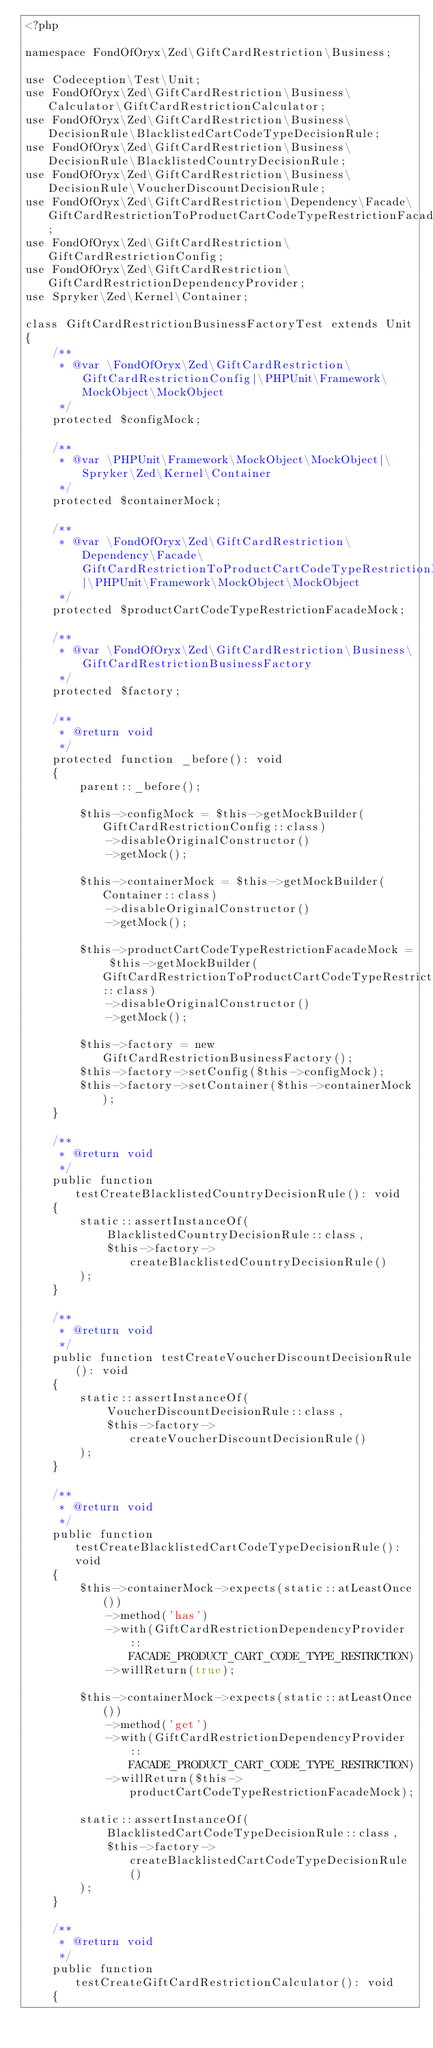Convert code to text. <code><loc_0><loc_0><loc_500><loc_500><_PHP_><?php

namespace FondOfOryx\Zed\GiftCardRestriction\Business;

use Codeception\Test\Unit;
use FondOfOryx\Zed\GiftCardRestriction\Business\Calculator\GiftCardRestrictionCalculator;
use FondOfOryx\Zed\GiftCardRestriction\Business\DecisionRule\BlacklistedCartCodeTypeDecisionRule;
use FondOfOryx\Zed\GiftCardRestriction\Business\DecisionRule\BlacklistedCountryDecisionRule;
use FondOfOryx\Zed\GiftCardRestriction\Business\DecisionRule\VoucherDiscountDecisionRule;
use FondOfOryx\Zed\GiftCardRestriction\Dependency\Facade\GiftCardRestrictionToProductCartCodeTypeRestrictionFacadeInterface;
use FondOfOryx\Zed\GiftCardRestriction\GiftCardRestrictionConfig;
use FondOfOryx\Zed\GiftCardRestriction\GiftCardRestrictionDependencyProvider;
use Spryker\Zed\Kernel\Container;

class GiftCardRestrictionBusinessFactoryTest extends Unit
{
    /**
     * @var \FondOfOryx\Zed\GiftCardRestriction\GiftCardRestrictionConfig|\PHPUnit\Framework\MockObject\MockObject
     */
    protected $configMock;

    /**
     * @var \PHPUnit\Framework\MockObject\MockObject|\Spryker\Zed\Kernel\Container
     */
    protected $containerMock;

    /**
     * @var \FondOfOryx\Zed\GiftCardRestriction\Dependency\Facade\GiftCardRestrictionToProductCartCodeTypeRestrictionFacadeInterface|\PHPUnit\Framework\MockObject\MockObject
     */
    protected $productCartCodeTypeRestrictionFacadeMock;

    /**
     * @var \FondOfOryx\Zed\GiftCardRestriction\Business\GiftCardRestrictionBusinessFactory
     */
    protected $factory;

    /**
     * @return void
     */
    protected function _before(): void
    {
        parent::_before();

        $this->configMock = $this->getMockBuilder(GiftCardRestrictionConfig::class)
            ->disableOriginalConstructor()
            ->getMock();

        $this->containerMock = $this->getMockBuilder(Container::class)
            ->disableOriginalConstructor()
            ->getMock();

        $this->productCartCodeTypeRestrictionFacadeMock = $this->getMockBuilder(GiftCardRestrictionToProductCartCodeTypeRestrictionFacadeInterface::class)
            ->disableOriginalConstructor()
            ->getMock();

        $this->factory = new GiftCardRestrictionBusinessFactory();
        $this->factory->setConfig($this->configMock);
        $this->factory->setContainer($this->containerMock);
    }

    /**
     * @return void
     */
    public function testCreateBlacklistedCountryDecisionRule(): void
    {
        static::assertInstanceOf(
            BlacklistedCountryDecisionRule::class,
            $this->factory->createBlacklistedCountryDecisionRule()
        );
    }

    /**
     * @return void
     */
    public function testCreateVoucherDiscountDecisionRule(): void
    {
        static::assertInstanceOf(
            VoucherDiscountDecisionRule::class,
            $this->factory->createVoucherDiscountDecisionRule()
        );
    }

    /**
     * @return void
     */
    public function testCreateBlacklistedCartCodeTypeDecisionRule(): void
    {
        $this->containerMock->expects(static::atLeastOnce())
            ->method('has')
            ->with(GiftCardRestrictionDependencyProvider::FACADE_PRODUCT_CART_CODE_TYPE_RESTRICTION)
            ->willReturn(true);

        $this->containerMock->expects(static::atLeastOnce())
            ->method('get')
            ->with(GiftCardRestrictionDependencyProvider::FACADE_PRODUCT_CART_CODE_TYPE_RESTRICTION)
            ->willReturn($this->productCartCodeTypeRestrictionFacadeMock);

        static::assertInstanceOf(
            BlacklistedCartCodeTypeDecisionRule::class,
            $this->factory->createBlacklistedCartCodeTypeDecisionRule()
        );
    }

    /**
     * @return void
     */
    public function testCreateGiftCardRestrictionCalculator(): void
    {</code> 